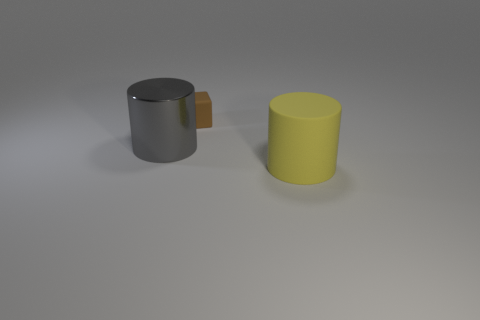Add 3 large red shiny things. How many objects exist? 6 Subtract all cylinders. How many objects are left? 1 Add 2 small rubber objects. How many small rubber objects are left? 3 Add 1 brown matte things. How many brown matte things exist? 2 Subtract 0 red blocks. How many objects are left? 3 Subtract all big gray cylinders. Subtract all gray cylinders. How many objects are left? 1 